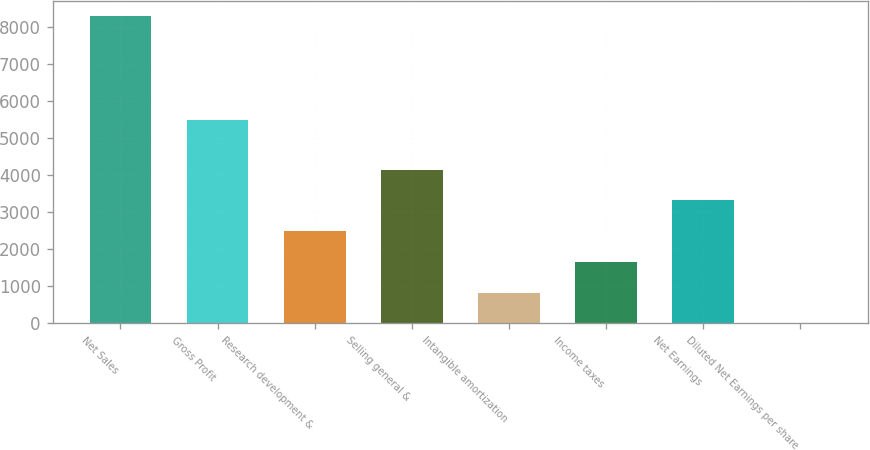<chart> <loc_0><loc_0><loc_500><loc_500><bar_chart><fcel>Net Sales<fcel>Gross Profit<fcel>Research development &<fcel>Selling general &<fcel>Intangible amortization<fcel>Income taxes<fcel>Net Earnings<fcel>Diluted Net Earnings per share<nl><fcel>8307<fcel>5496<fcel>2494.52<fcel>4155.24<fcel>833.81<fcel>1664.16<fcel>3324.88<fcel>3.45<nl></chart> 